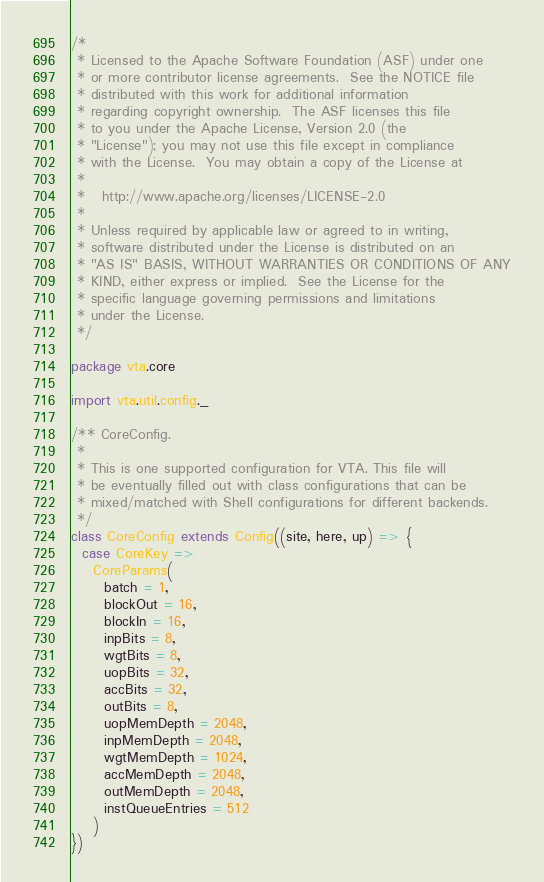Convert code to text. <code><loc_0><loc_0><loc_500><loc_500><_Scala_>/*
 * Licensed to the Apache Software Foundation (ASF) under one
 * or more contributor license agreements.  See the NOTICE file
 * distributed with this work for additional information
 * regarding copyright ownership.  The ASF licenses this file
 * to you under the Apache License, Version 2.0 (the
 * "License"); you may not use this file except in compliance
 * with the License.  You may obtain a copy of the License at
 *
 *   http://www.apache.org/licenses/LICENSE-2.0
 *
 * Unless required by applicable law or agreed to in writing,
 * software distributed under the License is distributed on an
 * "AS IS" BASIS, WITHOUT WARRANTIES OR CONDITIONS OF ANY
 * KIND, either express or implied.  See the License for the
 * specific language governing permissions and limitations
 * under the License.
 */

package vta.core

import vta.util.config._

/** CoreConfig.
 *
 * This is one supported configuration for VTA. This file will
 * be eventually filled out with class configurations that can be
 * mixed/matched with Shell configurations for different backends.
 */
class CoreConfig extends Config((site, here, up) => {
  case CoreKey =>
    CoreParams(
      batch = 1,
      blockOut = 16,
      blockIn = 16,
      inpBits = 8,
      wgtBits = 8,
      uopBits = 32,
      accBits = 32,
      outBits = 8,
      uopMemDepth = 2048,
      inpMemDepth = 2048,
      wgtMemDepth = 1024,
      accMemDepth = 2048,
      outMemDepth = 2048,
      instQueueEntries = 512
    )
})
</code> 